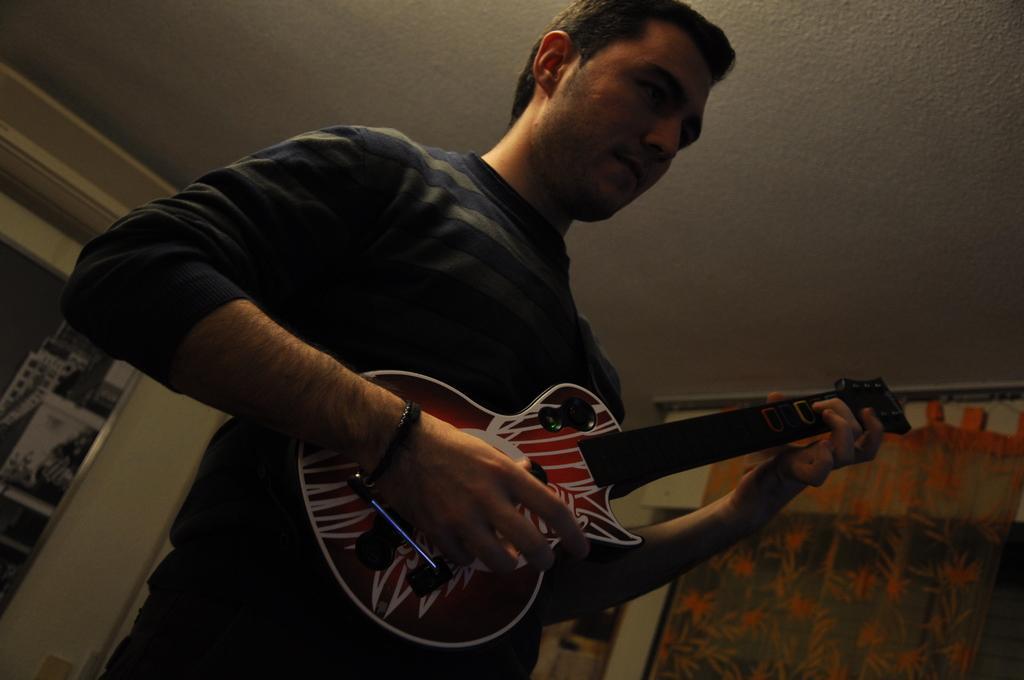Describe this image in one or two sentences. This picture shows a man standing and holding guitar and playing and we see curtain to the window 